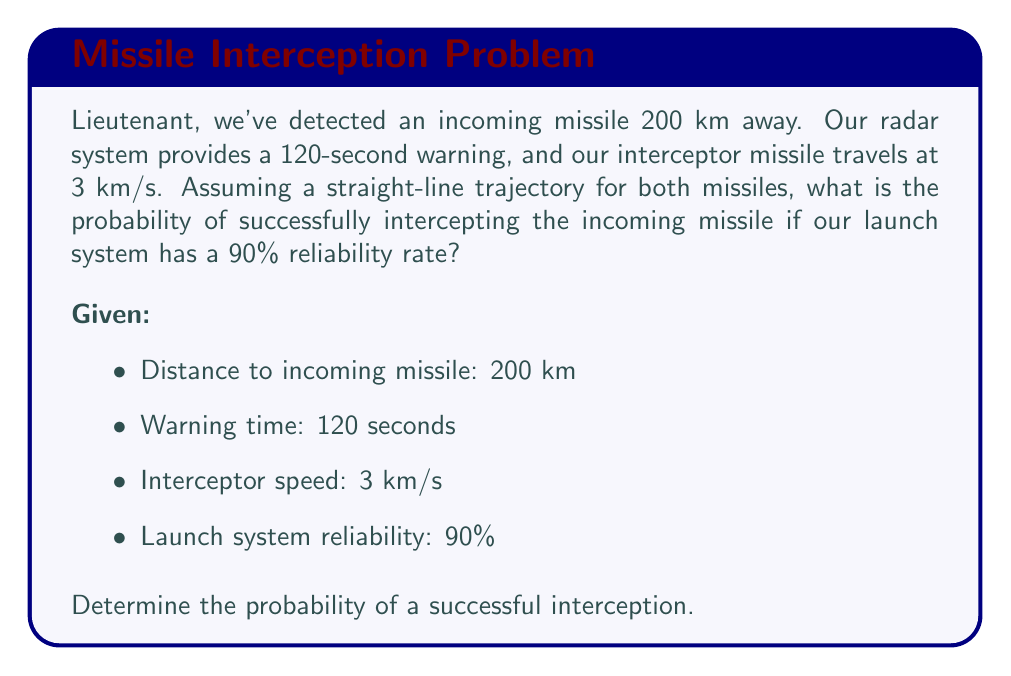Teach me how to tackle this problem. Let's approach this step-by-step, Lieutenant:

1) First, we need to determine if our interceptor can reach the incoming missile in time. Let's calculate the distance our interceptor can travel in 120 seconds:

   $$d_{interceptor} = v_{interceptor} \times t$$
   $$d_{interceptor} = 3 \text{ km/s} \times 120 \text{ s} = 360 \text{ km}$$

2) Since the interceptor can travel 360 km in the given time, and the incoming missile is only 200 km away, we can conclude that interception is possible.

3) Now, for a successful interception, two conditions must be met:
   a) The launch system must work (90% probability)
   b) The interceptor must hit the incoming missile (assumed 100% if launched successfully)

4) In probability theory, when we need both events to occur, we multiply their individual probabilities:

   $$P(\text{successful interception}) = P(\text{launch system works}) \times P(\text{interceptor hits | launch successful})$$
   $$P(\text{successful interception}) = 0.90 \times 1.00 = 0.90$$

5) Therefore, the probability of successfully intercepting the incoming missile is 0.90 or 90%.

[asy]
import geometry;

size(200);
draw((0,0)--(200,0), arrow=Arrow(TeXHead));
draw((0,0)--(0,50), arrow=Arrow(TeXHead));
label("Distance (km)", (100,-10));
label("Time (s)", (-10,25));

draw((0,0)--(200,40), blue);
label("Incoming Missile", (100,25), blue);

draw((0,0)--(360,40), red);
label("Interceptor", (180,25), red);

dot((200,40));
label("Interception Point", (200,50));
[/asy]
Answer: The probability of successfully intercepting the incoming missile is 90% or 0.90. 